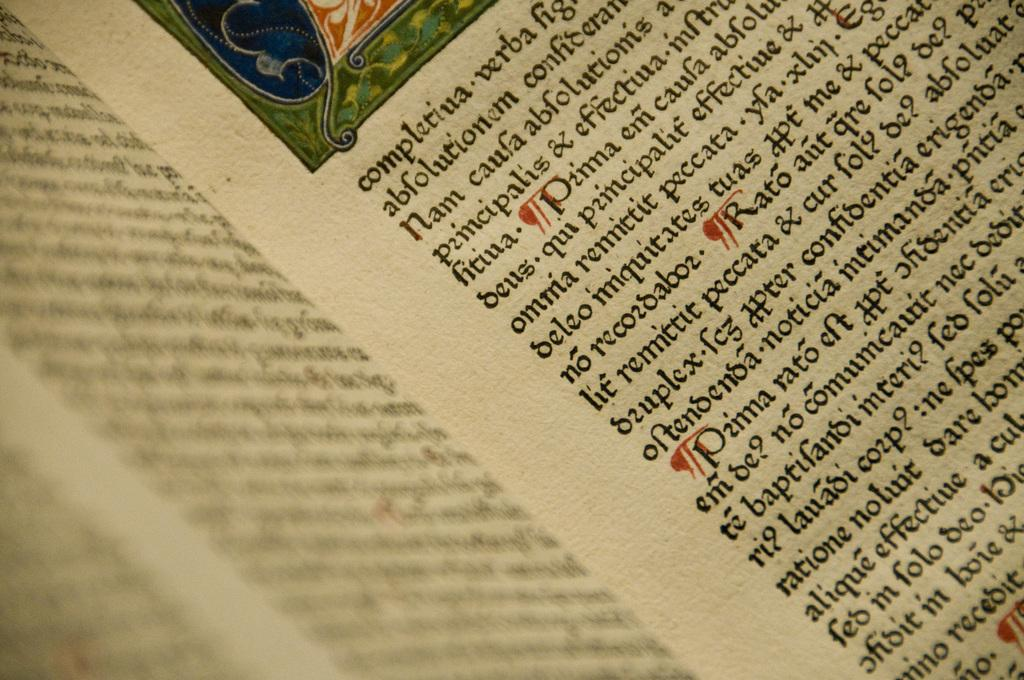Provide a one-sentence caption for the provided image. An open book reveals writing in a foreign language. 